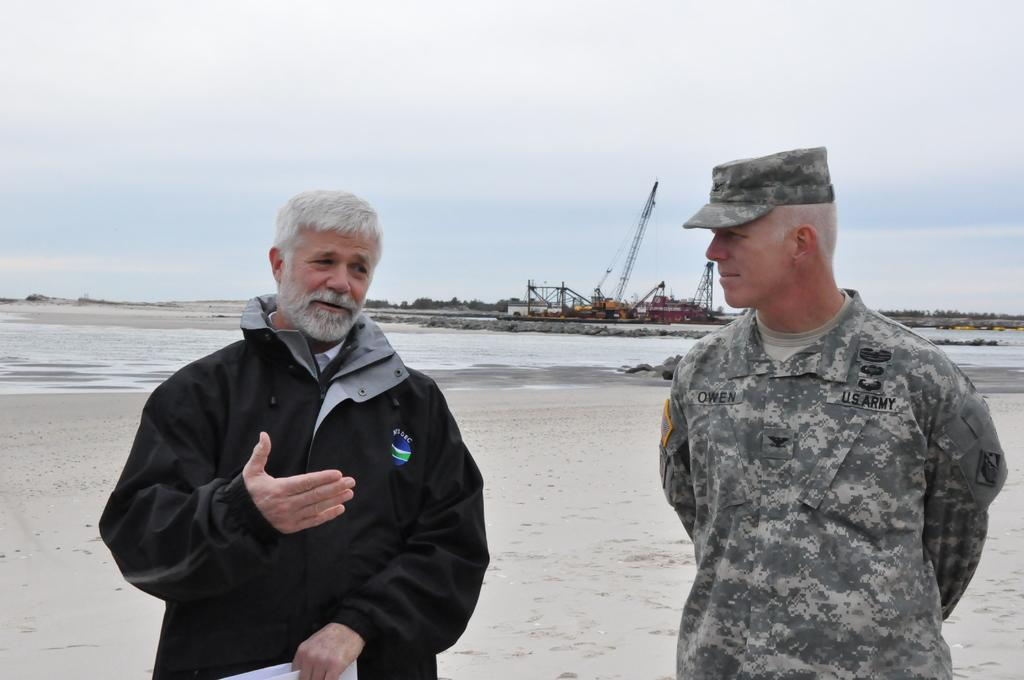What is the man in the image wearing? The man is wearing an army dress in the image. Who is the man looking at in the image? The man is looking at another person in the image. What is the other person wearing? The other person is wearing a jacket. What is the other person holding in the image? The other person is holding an object. What can be seen in the distance in the image? There are cranes and trees in the distance. What is visible in the background of the image? The sky is visible in the background of the image. What type of watch is the man wearing in the image? There is no watch visible on the man in the image. What kind of pets are present in the image? There are no pets present in the image. 